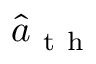Convert formula to latex. <formula><loc_0><loc_0><loc_500><loc_500>\hat { a } _ { t h }</formula> 